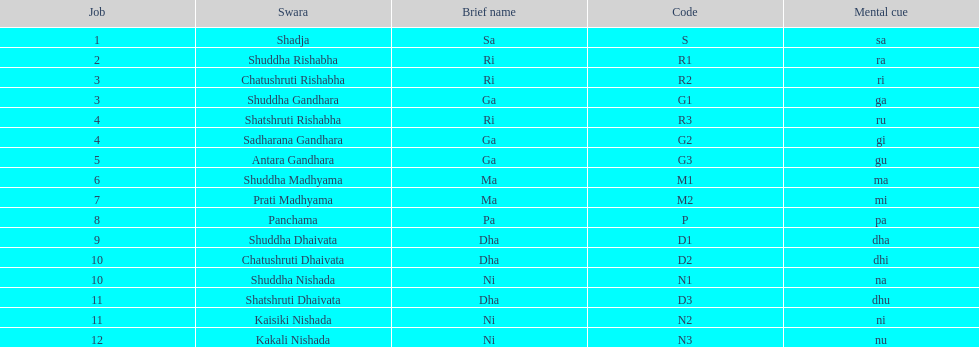I'm looking to parse the entire table for insights. Could you assist me with that? {'header': ['Job', 'Swara', 'Brief name', 'Code', 'Mental cue'], 'rows': [['1', 'Shadja', 'Sa', 'S', 'sa'], ['2', 'Shuddha Rishabha', 'Ri', 'R1', 'ra'], ['3', 'Chatushruti Rishabha', 'Ri', 'R2', 'ri'], ['3', 'Shuddha Gandhara', 'Ga', 'G1', 'ga'], ['4', 'Shatshruti Rishabha', 'Ri', 'R3', 'ru'], ['4', 'Sadharana Gandhara', 'Ga', 'G2', 'gi'], ['5', 'Antara Gandhara', 'Ga', 'G3', 'gu'], ['6', 'Shuddha Madhyama', 'Ma', 'M1', 'ma'], ['7', 'Prati Madhyama', 'Ma', 'M2', 'mi'], ['8', 'Panchama', 'Pa', 'P', 'pa'], ['9', 'Shuddha Dhaivata', 'Dha', 'D1', 'dha'], ['10', 'Chatushruti Dhaivata', 'Dha', 'D2', 'dhi'], ['10', 'Shuddha Nishada', 'Ni', 'N1', 'na'], ['11', 'Shatshruti Dhaivata', 'Dha', 'D3', 'dhu'], ['11', 'Kaisiki Nishada', 'Ni', 'N2', 'ni'], ['12', 'Kakali Nishada', 'Ni', 'N3', 'nu']]} Which swara holds the last position? Kakali Nishada. 